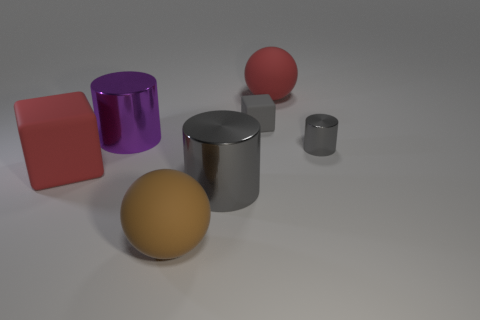Subtract all big gray cylinders. How many cylinders are left? 2 Subtract all yellow spheres. How many gray cylinders are left? 2 Subtract 1 cylinders. How many cylinders are left? 2 Add 1 gray matte cubes. How many objects exist? 8 Subtract all blocks. How many objects are left? 5 Subtract 0 green cubes. How many objects are left? 7 Subtract all tiny cylinders. Subtract all tiny gray matte cubes. How many objects are left? 5 Add 6 tiny objects. How many tiny objects are left? 8 Add 5 big red matte cubes. How many big red matte cubes exist? 6 